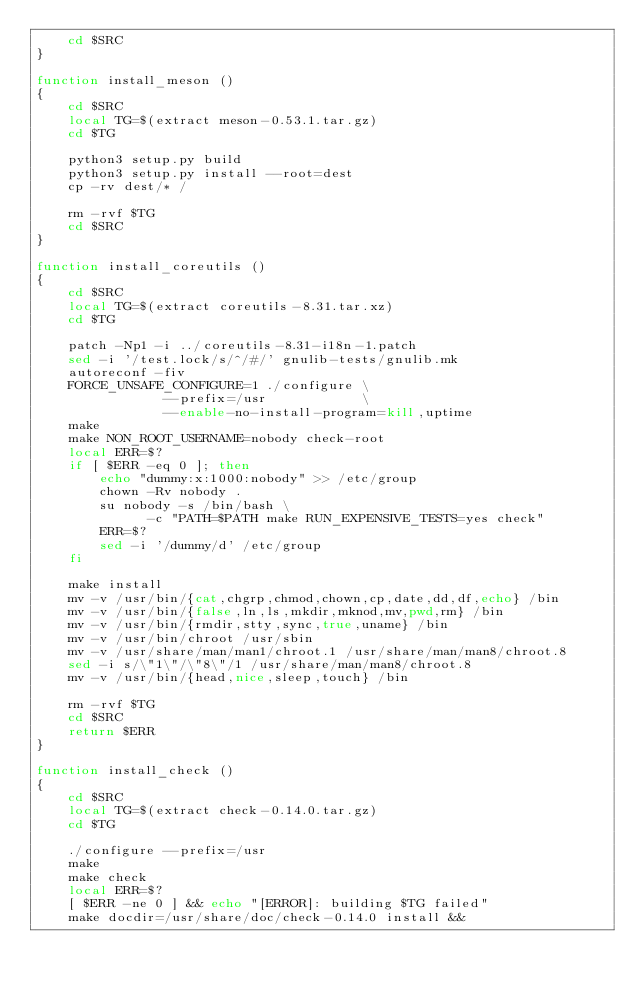Convert code to text. <code><loc_0><loc_0><loc_500><loc_500><_Bash_>    cd $SRC
}

function install_meson ()
{
    cd $SRC
    local TG=$(extract meson-0.53.1.tar.gz)
    cd $TG

    python3 setup.py build
    python3 setup.py install --root=dest
    cp -rv dest/* /

    rm -rvf $TG
    cd $SRC
}

function install_coreutils ()
{
    cd $SRC
    local TG=$(extract coreutils-8.31.tar.xz)
    cd $TG

    patch -Np1 -i ../coreutils-8.31-i18n-1.patch
    sed -i '/test.lock/s/^/#/' gnulib-tests/gnulib.mk
    autoreconf -fiv
    FORCE_UNSAFE_CONFIGURE=1 ./configure \
                --prefix=/usr            \
                --enable-no-install-program=kill,uptime
    make
    make NON_ROOT_USERNAME=nobody check-root
    local ERR=$?
    if [ $ERR -eq 0 ]; then
    	echo "dummy:x:1000:nobody" >> /etc/group
    	chown -Rv nobody . 
    	su nobody -s /bin/bash \
              -c "PATH=$PATH make RUN_EXPENSIVE_TESTS=yes check"
    	ERR=$?
    	sed -i '/dummy/d' /etc/group
    fi			

    make install 
    mv -v /usr/bin/{cat,chgrp,chmod,chown,cp,date,dd,df,echo} /bin
    mv -v /usr/bin/{false,ln,ls,mkdir,mknod,mv,pwd,rm} /bin
    mv -v /usr/bin/{rmdir,stty,sync,true,uname} /bin
    mv -v /usr/bin/chroot /usr/sbin
    mv -v /usr/share/man/man1/chroot.1 /usr/share/man/man8/chroot.8
    sed -i s/\"1\"/\"8\"/1 /usr/share/man/man8/chroot.8
    mv -v /usr/bin/{head,nice,sleep,touch} /bin

    rm -rvf $TG
    cd $SRC
    return $ERR
}

function install_check ()
{
    cd $SRC
    local TG=$(extract check-0.14.0.tar.gz)
    cd $TG

    ./configure --prefix=/usr
    make
    make check
    local ERR=$?
    [ $ERR -ne 0 ] && echo "[ERROR]: building $TG failed"
    make docdir=/usr/share/doc/check-0.14.0 install &&</code> 